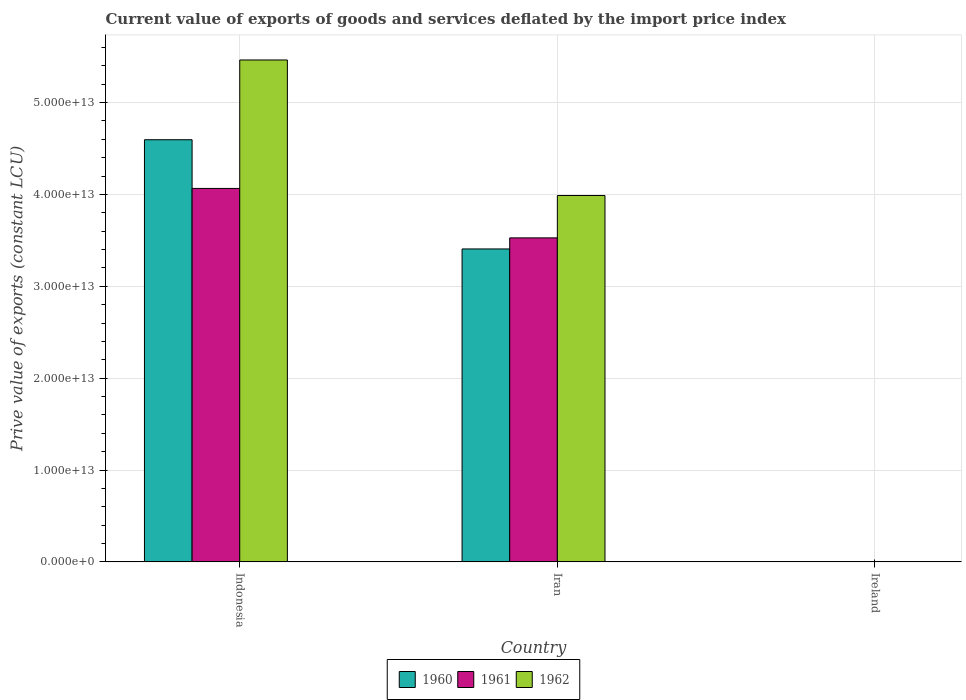Are the number of bars on each tick of the X-axis equal?
Make the answer very short. Yes. How many bars are there on the 3rd tick from the left?
Provide a short and direct response. 3. How many bars are there on the 2nd tick from the right?
Provide a short and direct response. 3. What is the label of the 1st group of bars from the left?
Make the answer very short. Indonesia. In how many cases, is the number of bars for a given country not equal to the number of legend labels?
Make the answer very short. 0. What is the prive value of exports in 1961 in Indonesia?
Offer a very short reply. 4.07e+13. Across all countries, what is the maximum prive value of exports in 1961?
Give a very brief answer. 4.07e+13. Across all countries, what is the minimum prive value of exports in 1960?
Keep it short and to the point. 2.78e+09. In which country was the prive value of exports in 1961 minimum?
Provide a succinct answer. Ireland. What is the total prive value of exports in 1962 in the graph?
Ensure brevity in your answer.  9.45e+13. What is the difference between the prive value of exports in 1961 in Indonesia and that in Iran?
Make the answer very short. 5.38e+12. What is the difference between the prive value of exports in 1962 in Iran and the prive value of exports in 1961 in Indonesia?
Make the answer very short. -7.73e+11. What is the average prive value of exports in 1960 per country?
Provide a short and direct response. 2.67e+13. What is the difference between the prive value of exports of/in 1960 and prive value of exports of/in 1962 in Indonesia?
Offer a terse response. -8.68e+12. In how many countries, is the prive value of exports in 1962 greater than 10000000000000 LCU?
Your answer should be compact. 2. What is the ratio of the prive value of exports in 1960 in Indonesia to that in Iran?
Provide a succinct answer. 1.35. Is the prive value of exports in 1962 in Indonesia less than that in Ireland?
Your response must be concise. No. What is the difference between the highest and the second highest prive value of exports in 1960?
Provide a short and direct response. -4.59e+13. What is the difference between the highest and the lowest prive value of exports in 1960?
Provide a short and direct response. 4.59e+13. In how many countries, is the prive value of exports in 1962 greater than the average prive value of exports in 1962 taken over all countries?
Make the answer very short. 2. What does the 1st bar from the right in Ireland represents?
Keep it short and to the point. 1962. Is it the case that in every country, the sum of the prive value of exports in 1961 and prive value of exports in 1962 is greater than the prive value of exports in 1960?
Provide a short and direct response. Yes. How many bars are there?
Your answer should be compact. 9. What is the difference between two consecutive major ticks on the Y-axis?
Your response must be concise. 1.00e+13. Does the graph contain grids?
Make the answer very short. Yes. What is the title of the graph?
Your answer should be very brief. Current value of exports of goods and services deflated by the import price index. Does "1984" appear as one of the legend labels in the graph?
Offer a terse response. No. What is the label or title of the X-axis?
Offer a terse response. Country. What is the label or title of the Y-axis?
Ensure brevity in your answer.  Prive value of exports (constant LCU). What is the Prive value of exports (constant LCU) in 1960 in Indonesia?
Offer a very short reply. 4.60e+13. What is the Prive value of exports (constant LCU) in 1961 in Indonesia?
Offer a terse response. 4.07e+13. What is the Prive value of exports (constant LCU) of 1962 in Indonesia?
Ensure brevity in your answer.  5.46e+13. What is the Prive value of exports (constant LCU) in 1960 in Iran?
Keep it short and to the point. 3.41e+13. What is the Prive value of exports (constant LCU) of 1961 in Iran?
Keep it short and to the point. 3.53e+13. What is the Prive value of exports (constant LCU) of 1962 in Iran?
Give a very brief answer. 3.99e+13. What is the Prive value of exports (constant LCU) of 1960 in Ireland?
Provide a short and direct response. 2.78e+09. What is the Prive value of exports (constant LCU) in 1961 in Ireland?
Offer a terse response. 3.22e+09. What is the Prive value of exports (constant LCU) of 1962 in Ireland?
Keep it short and to the point. 3.23e+09. Across all countries, what is the maximum Prive value of exports (constant LCU) of 1960?
Offer a terse response. 4.60e+13. Across all countries, what is the maximum Prive value of exports (constant LCU) in 1961?
Make the answer very short. 4.07e+13. Across all countries, what is the maximum Prive value of exports (constant LCU) of 1962?
Your response must be concise. 5.46e+13. Across all countries, what is the minimum Prive value of exports (constant LCU) of 1960?
Offer a terse response. 2.78e+09. Across all countries, what is the minimum Prive value of exports (constant LCU) of 1961?
Keep it short and to the point. 3.22e+09. Across all countries, what is the minimum Prive value of exports (constant LCU) of 1962?
Provide a short and direct response. 3.23e+09. What is the total Prive value of exports (constant LCU) in 1960 in the graph?
Offer a very short reply. 8.00e+13. What is the total Prive value of exports (constant LCU) of 1961 in the graph?
Make the answer very short. 7.59e+13. What is the total Prive value of exports (constant LCU) in 1962 in the graph?
Offer a terse response. 9.45e+13. What is the difference between the Prive value of exports (constant LCU) of 1960 in Indonesia and that in Iran?
Your answer should be very brief. 1.19e+13. What is the difference between the Prive value of exports (constant LCU) in 1961 in Indonesia and that in Iran?
Your response must be concise. 5.38e+12. What is the difference between the Prive value of exports (constant LCU) of 1962 in Indonesia and that in Iran?
Give a very brief answer. 1.48e+13. What is the difference between the Prive value of exports (constant LCU) in 1960 in Indonesia and that in Ireland?
Make the answer very short. 4.59e+13. What is the difference between the Prive value of exports (constant LCU) of 1961 in Indonesia and that in Ireland?
Provide a succinct answer. 4.06e+13. What is the difference between the Prive value of exports (constant LCU) of 1962 in Indonesia and that in Ireland?
Ensure brevity in your answer.  5.46e+13. What is the difference between the Prive value of exports (constant LCU) in 1960 in Iran and that in Ireland?
Make the answer very short. 3.41e+13. What is the difference between the Prive value of exports (constant LCU) in 1961 in Iran and that in Ireland?
Offer a terse response. 3.53e+13. What is the difference between the Prive value of exports (constant LCU) in 1962 in Iran and that in Ireland?
Offer a very short reply. 3.99e+13. What is the difference between the Prive value of exports (constant LCU) of 1960 in Indonesia and the Prive value of exports (constant LCU) of 1961 in Iran?
Provide a succinct answer. 1.07e+13. What is the difference between the Prive value of exports (constant LCU) in 1960 in Indonesia and the Prive value of exports (constant LCU) in 1962 in Iran?
Your answer should be compact. 6.07e+12. What is the difference between the Prive value of exports (constant LCU) of 1961 in Indonesia and the Prive value of exports (constant LCU) of 1962 in Iran?
Make the answer very short. 7.73e+11. What is the difference between the Prive value of exports (constant LCU) of 1960 in Indonesia and the Prive value of exports (constant LCU) of 1961 in Ireland?
Your answer should be compact. 4.59e+13. What is the difference between the Prive value of exports (constant LCU) in 1960 in Indonesia and the Prive value of exports (constant LCU) in 1962 in Ireland?
Provide a succinct answer. 4.59e+13. What is the difference between the Prive value of exports (constant LCU) in 1961 in Indonesia and the Prive value of exports (constant LCU) in 1962 in Ireland?
Your answer should be very brief. 4.06e+13. What is the difference between the Prive value of exports (constant LCU) in 1960 in Iran and the Prive value of exports (constant LCU) in 1961 in Ireland?
Offer a terse response. 3.41e+13. What is the difference between the Prive value of exports (constant LCU) in 1960 in Iran and the Prive value of exports (constant LCU) in 1962 in Ireland?
Provide a succinct answer. 3.41e+13. What is the difference between the Prive value of exports (constant LCU) of 1961 in Iran and the Prive value of exports (constant LCU) of 1962 in Ireland?
Keep it short and to the point. 3.53e+13. What is the average Prive value of exports (constant LCU) in 1960 per country?
Keep it short and to the point. 2.67e+13. What is the average Prive value of exports (constant LCU) in 1961 per country?
Offer a very short reply. 2.53e+13. What is the average Prive value of exports (constant LCU) in 1962 per country?
Offer a very short reply. 3.15e+13. What is the difference between the Prive value of exports (constant LCU) of 1960 and Prive value of exports (constant LCU) of 1961 in Indonesia?
Offer a very short reply. 5.30e+12. What is the difference between the Prive value of exports (constant LCU) of 1960 and Prive value of exports (constant LCU) of 1962 in Indonesia?
Your response must be concise. -8.68e+12. What is the difference between the Prive value of exports (constant LCU) of 1961 and Prive value of exports (constant LCU) of 1962 in Indonesia?
Ensure brevity in your answer.  -1.40e+13. What is the difference between the Prive value of exports (constant LCU) of 1960 and Prive value of exports (constant LCU) of 1961 in Iran?
Provide a short and direct response. -1.21e+12. What is the difference between the Prive value of exports (constant LCU) of 1960 and Prive value of exports (constant LCU) of 1962 in Iran?
Ensure brevity in your answer.  -5.81e+12. What is the difference between the Prive value of exports (constant LCU) in 1961 and Prive value of exports (constant LCU) in 1962 in Iran?
Keep it short and to the point. -4.61e+12. What is the difference between the Prive value of exports (constant LCU) of 1960 and Prive value of exports (constant LCU) of 1961 in Ireland?
Your answer should be compact. -4.39e+08. What is the difference between the Prive value of exports (constant LCU) in 1960 and Prive value of exports (constant LCU) in 1962 in Ireland?
Offer a terse response. -4.49e+08. What is the difference between the Prive value of exports (constant LCU) of 1961 and Prive value of exports (constant LCU) of 1962 in Ireland?
Your answer should be very brief. -9.94e+06. What is the ratio of the Prive value of exports (constant LCU) of 1960 in Indonesia to that in Iran?
Keep it short and to the point. 1.35. What is the ratio of the Prive value of exports (constant LCU) of 1961 in Indonesia to that in Iran?
Ensure brevity in your answer.  1.15. What is the ratio of the Prive value of exports (constant LCU) of 1962 in Indonesia to that in Iran?
Provide a short and direct response. 1.37. What is the ratio of the Prive value of exports (constant LCU) of 1960 in Indonesia to that in Ireland?
Offer a very short reply. 1.65e+04. What is the ratio of the Prive value of exports (constant LCU) in 1961 in Indonesia to that in Ireland?
Your response must be concise. 1.26e+04. What is the ratio of the Prive value of exports (constant LCU) of 1962 in Indonesia to that in Ireland?
Make the answer very short. 1.69e+04. What is the ratio of the Prive value of exports (constant LCU) in 1960 in Iran to that in Ireland?
Your answer should be compact. 1.23e+04. What is the ratio of the Prive value of exports (constant LCU) of 1961 in Iran to that in Ireland?
Offer a very short reply. 1.10e+04. What is the ratio of the Prive value of exports (constant LCU) in 1962 in Iran to that in Ireland?
Ensure brevity in your answer.  1.24e+04. What is the difference between the highest and the second highest Prive value of exports (constant LCU) of 1960?
Your response must be concise. 1.19e+13. What is the difference between the highest and the second highest Prive value of exports (constant LCU) of 1961?
Provide a succinct answer. 5.38e+12. What is the difference between the highest and the second highest Prive value of exports (constant LCU) in 1962?
Offer a terse response. 1.48e+13. What is the difference between the highest and the lowest Prive value of exports (constant LCU) of 1960?
Provide a succinct answer. 4.59e+13. What is the difference between the highest and the lowest Prive value of exports (constant LCU) in 1961?
Offer a very short reply. 4.06e+13. What is the difference between the highest and the lowest Prive value of exports (constant LCU) in 1962?
Keep it short and to the point. 5.46e+13. 